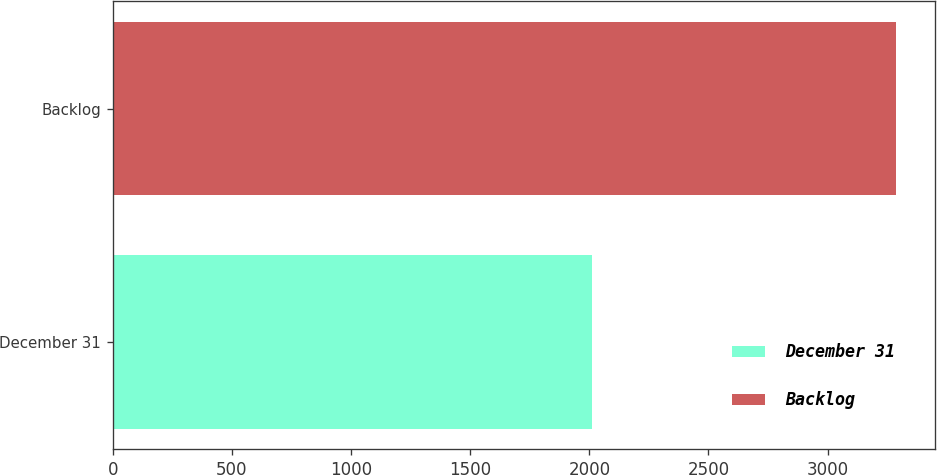<chart> <loc_0><loc_0><loc_500><loc_500><bar_chart><fcel>December 31<fcel>Backlog<nl><fcel>2013<fcel>3286<nl></chart> 